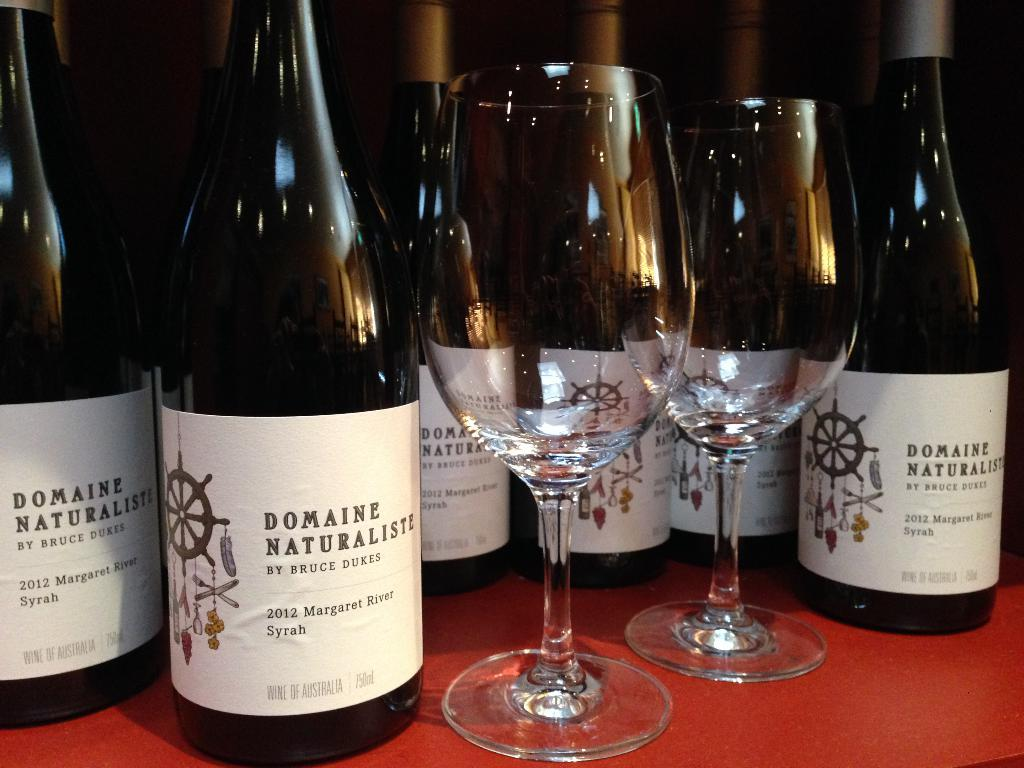<image>
Render a clear and concise summary of the photo. Six glass bottles of Domaine Naturalistic by Bruce Dukes. 